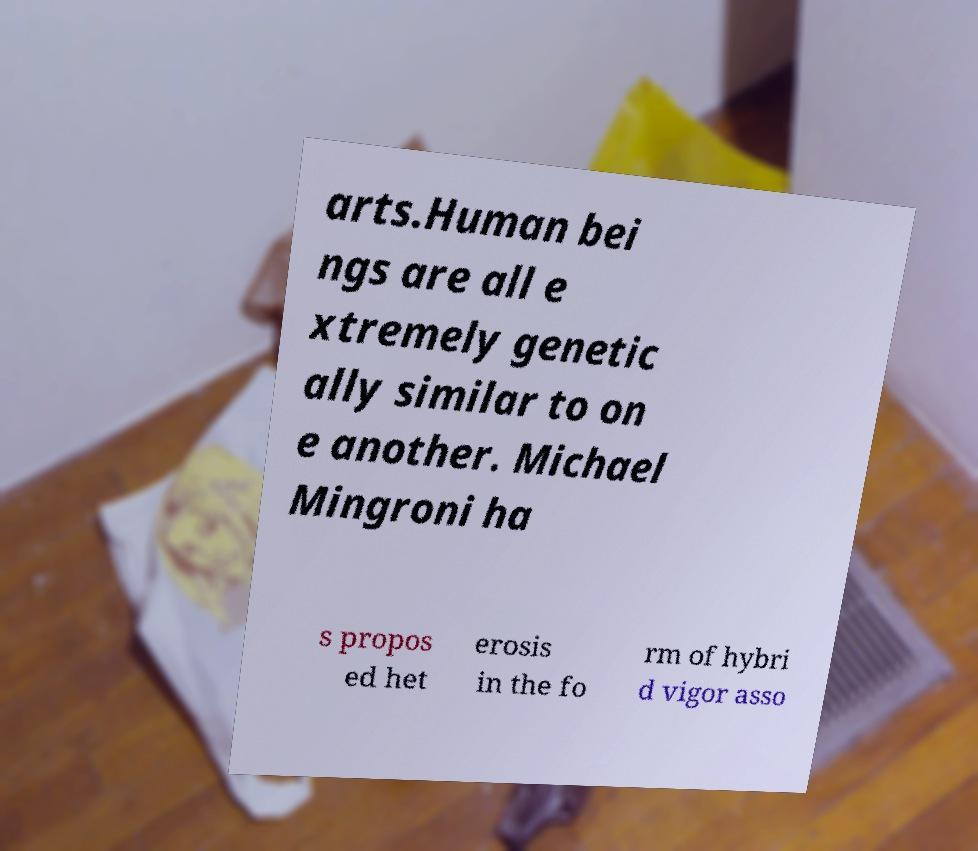Could you assist in decoding the text presented in this image and type it out clearly? arts.Human bei ngs are all e xtremely genetic ally similar to on e another. Michael Mingroni ha s propos ed het erosis in the fo rm of hybri d vigor asso 